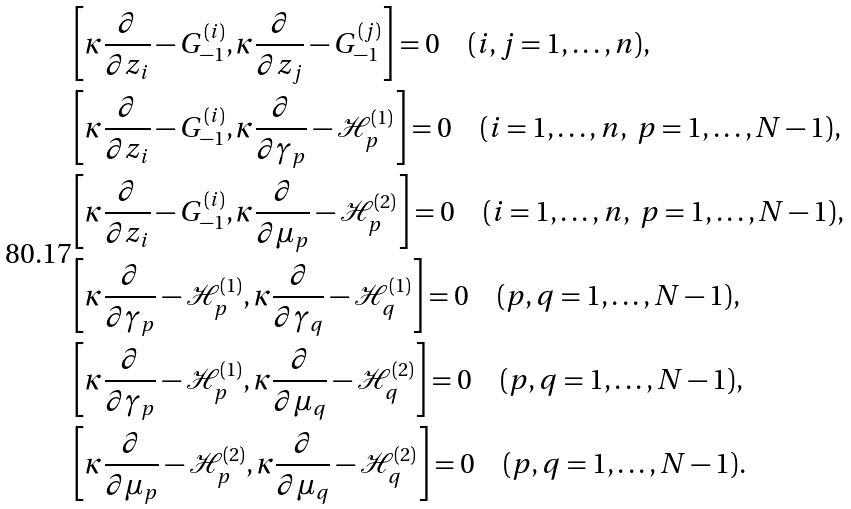Convert formula to latex. <formula><loc_0><loc_0><loc_500><loc_500>& \left [ \kappa \frac { \partial } { \partial z _ { i } } - G ^ { ( i ) } _ { - 1 } , \kappa \frac { \partial } { \partial z _ { j } } - G ^ { ( j ) } _ { - 1 } \right ] = 0 \quad ( i , j = 1 , \dots , n ) , \\ & \left [ \kappa \frac { \partial } { \partial z _ { i } } - G ^ { ( i ) } _ { - 1 } , \kappa \frac { \partial } { \partial \gamma _ { p } } - \mathcal { H } ^ { ( 1 ) } _ { p } \right ] = 0 \quad ( i = 1 , \dots , n , \ p = 1 , \dots , N - 1 ) , \\ & \left [ \kappa \frac { \partial } { \partial z _ { i } } - G ^ { ( i ) } _ { - 1 } , \kappa \frac { \partial } { \partial \mu _ { p } } - \mathcal { H } ^ { ( 2 ) } _ { p } \right ] = 0 \quad ( i = 1 , \dots , n , \ p = 1 , \dots , N - 1 ) , \\ & \left [ \kappa \frac { \partial } { \partial \gamma _ { p } } - \mathcal { H } ^ { ( 1 ) } _ { p } , \kappa \frac { \partial } { \partial \gamma _ { q } } - \mathcal { H } ^ { ( 1 ) } _ { q } \right ] = 0 \quad ( p , q = 1 , \dots , N - 1 ) , \\ & \left [ \kappa \frac { \partial } { \partial \gamma _ { p } } - \mathcal { H } ^ { ( 1 ) } _ { p } , \kappa \frac { \partial } { \partial \mu _ { q } } - \mathcal { H } ^ { ( 2 ) } _ { q } \right ] = 0 \quad ( p , q = 1 , \dots , N - 1 ) , \\ & \left [ \kappa \frac { \partial } { \partial \mu _ { p } } - \mathcal { H } ^ { ( 2 ) } _ { p } , \kappa \frac { \partial } { \partial \mu _ { q } } - \mathcal { H } ^ { ( 2 ) } _ { q } \right ] = 0 \quad ( p , q = 1 , \dots , N - 1 ) .</formula> 